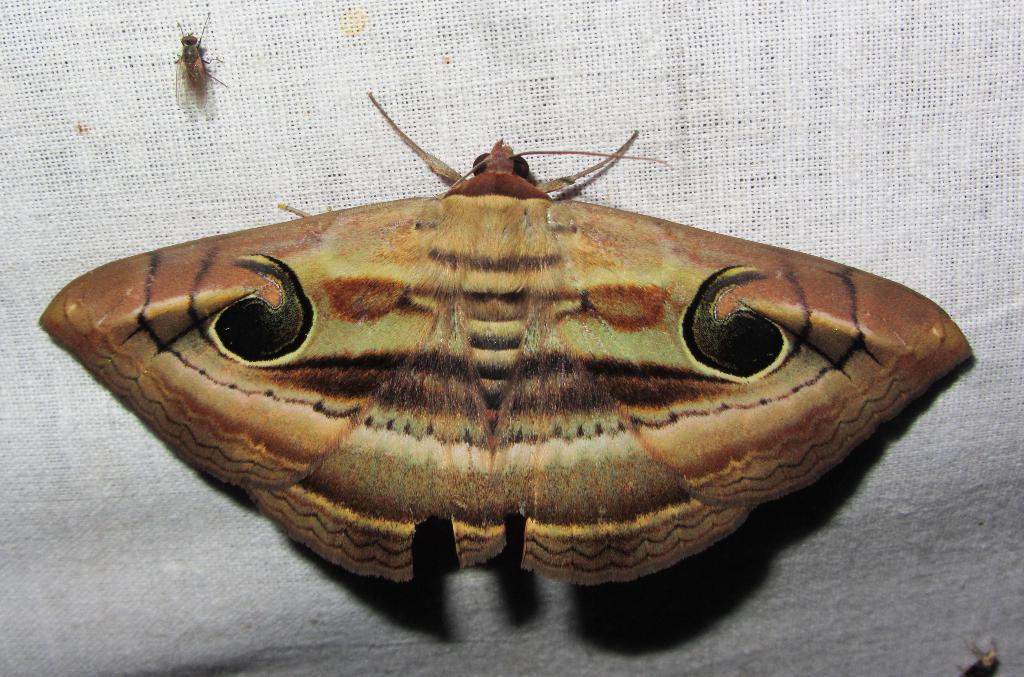What insect is present in the image? There is a moth in the image. Can you describe the color pattern of the moth? The moth has black and brown colors. What other insect is present in the image? There is a housefly in the image. What is the color of the background in the image? The background of the image is white in color. What might the white background be made of? The white background might be a cloth or a sheet. What type of cemetery can be seen in the image? There is no cemetery present in the image; it features a moth and a housefly against a white background. What territory is being claimed by the moth in the image? The moth is not claiming any territory in the image; it is simply resting on the white background. 